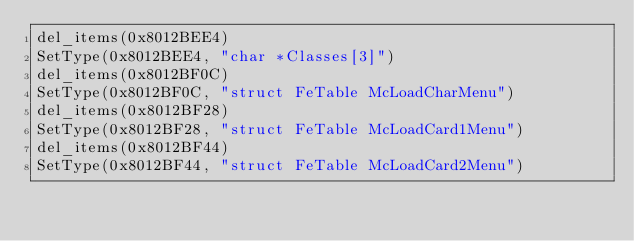<code> <loc_0><loc_0><loc_500><loc_500><_Python_>del_items(0x8012BEE4)
SetType(0x8012BEE4, "char *Classes[3]")
del_items(0x8012BF0C)
SetType(0x8012BF0C, "struct FeTable McLoadCharMenu")
del_items(0x8012BF28)
SetType(0x8012BF28, "struct FeTable McLoadCard1Menu")
del_items(0x8012BF44)
SetType(0x8012BF44, "struct FeTable McLoadCard2Menu")
</code> 